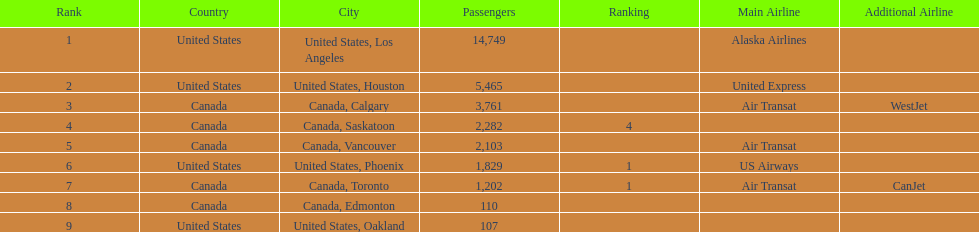Los angeles and what other city had about 19,000 passenger combined Canada, Calgary. 